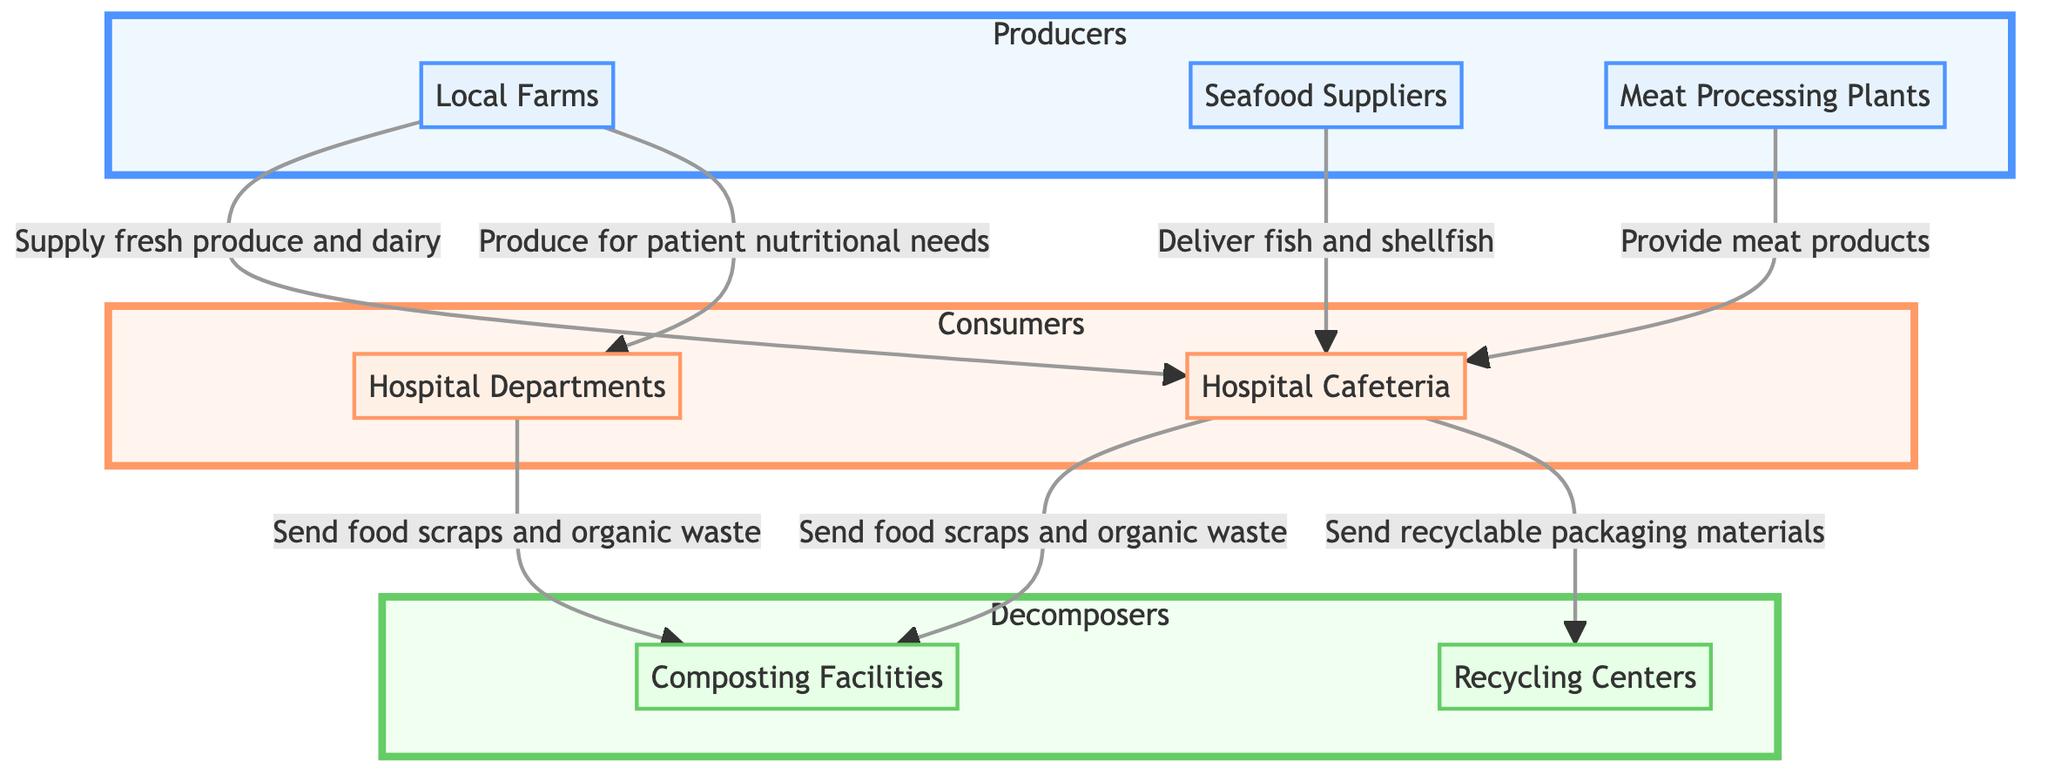What are the three types of producers in the diagram? The diagram lists three producers: Local Farms, Seafood Suppliers, and Meat Processing Plants. These are the sources that supply food to the hospital cafeteria.
Answer: Local Farms, Seafood Suppliers, Meat Processing Plants How many consumer nodes are present in the diagram? There are two consumer nodes: Hospital Cafeteria and Hospital Departments. These nodes represent where the food is utilized within the hospital setting.
Answer: 2 What type of food does the Local Farms supply to the Hospital Cafeteria? The Local Farms supply fresh produce and dairy to the Hospital Cafeteria. This indicates the specific types of food sourced from this producer.
Answer: Fresh produce and dairy Where do the food scraps and organic waste from the Hospital Cafeteria go? The food scraps and organic waste from the Hospital Cafeteria are sent to composting facilities. This indicates the waste management process in place for sustainability.
Answer: Composting Facilities What type of waste management takes the recyclable packaging materials from the Hospital Cafeteria? The recyclable packaging materials are sent to recycling centers, showing the part of the supply chain that focuses on recycling efforts.
Answer: Recycling Centers How do Hospital Departments utilize food from Local Farms? The Hospital Departments utilize food produced specifically for patient nutritional needs, indicating a tailored approach to food service within the hospital.
Answer: Patient nutritional needs What links the Meat Processing Plants to the Hospital Cafeteria? The link indicates that Meat Processing Plants provide meat products, establishing the flow of food from this producer to the consumer.
Answer: Provide meat products What relationship exists between Hospital Departments and Composting Facilities? The food scraps and organic waste from the Hospital Departments are sent to composting facilities, just like the waste from the Hospital Cafeteria, indicating a consistent waste management strategy.
Answer: Send food scraps and organic waste 